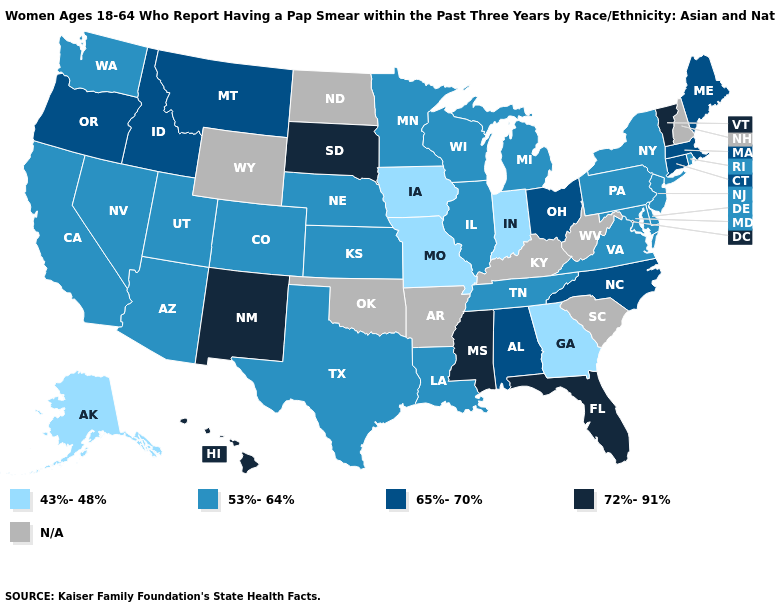Is the legend a continuous bar?
Quick response, please. No. Does the first symbol in the legend represent the smallest category?
Keep it brief. Yes. What is the value of Illinois?
Short answer required. 53%-64%. Does Vermont have the highest value in the USA?
Write a very short answer. Yes. Among the states that border Montana , does South Dakota have the highest value?
Be succinct. Yes. Name the states that have a value in the range 72%-91%?
Concise answer only. Florida, Hawaii, Mississippi, New Mexico, South Dakota, Vermont. What is the value of Wisconsin?
Keep it brief. 53%-64%. What is the highest value in the USA?
Write a very short answer. 72%-91%. Name the states that have a value in the range 53%-64%?
Be succinct. Arizona, California, Colorado, Delaware, Illinois, Kansas, Louisiana, Maryland, Michigan, Minnesota, Nebraska, Nevada, New Jersey, New York, Pennsylvania, Rhode Island, Tennessee, Texas, Utah, Virginia, Washington, Wisconsin. What is the lowest value in the USA?
Be succinct. 43%-48%. Does Washington have the lowest value in the West?
Answer briefly. No. How many symbols are there in the legend?
Concise answer only. 5. What is the value of New Jersey?
Write a very short answer. 53%-64%. 